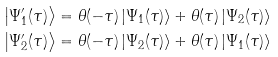Convert formula to latex. <formula><loc_0><loc_0><loc_500><loc_500>\left | \Psi ^ { \prime } _ { 1 } ( \tau ) \right \rangle & = \theta ( - \tau ) \left | \Psi _ { 1 } ( \tau ) \right \rangle + \theta ( \tau ) \left | \Psi _ { 2 } ( \tau ) \right \rangle \\ \left | \Psi ^ { \prime } _ { 2 } ( \tau ) \right \rangle & = \theta ( - \tau ) \left | \Psi _ { 2 } ( \tau ) \right \rangle + \theta ( \tau ) \left | \Psi _ { 1 } ( \tau ) \right \rangle</formula> 